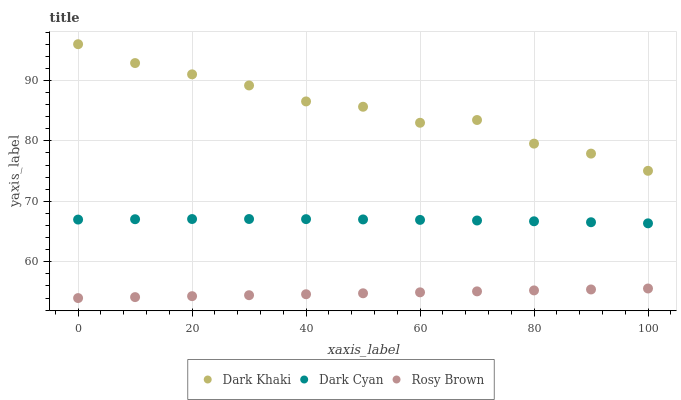Does Rosy Brown have the minimum area under the curve?
Answer yes or no. Yes. Does Dark Khaki have the maximum area under the curve?
Answer yes or no. Yes. Does Dark Cyan have the minimum area under the curve?
Answer yes or no. No. Does Dark Cyan have the maximum area under the curve?
Answer yes or no. No. Is Rosy Brown the smoothest?
Answer yes or no. Yes. Is Dark Khaki the roughest?
Answer yes or no. Yes. Is Dark Cyan the smoothest?
Answer yes or no. No. Is Dark Cyan the roughest?
Answer yes or no. No. Does Rosy Brown have the lowest value?
Answer yes or no. Yes. Does Dark Cyan have the lowest value?
Answer yes or no. No. Does Dark Khaki have the highest value?
Answer yes or no. Yes. Does Dark Cyan have the highest value?
Answer yes or no. No. Is Rosy Brown less than Dark Khaki?
Answer yes or no. Yes. Is Dark Khaki greater than Rosy Brown?
Answer yes or no. Yes. Does Rosy Brown intersect Dark Khaki?
Answer yes or no. No. 